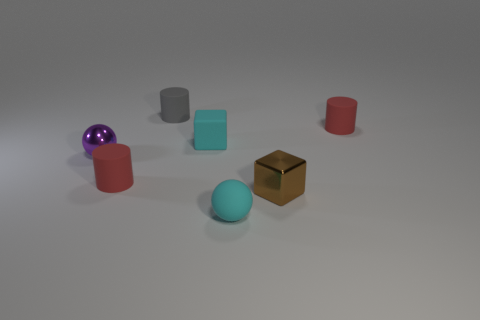Are there any objects in the image that seem out of place? In the context of the image, all objects seem to have been deliberately placed with space around them. Nothing appears to be out of place. They all rest on what looks like a neutral surface which suggests a controlled setup, perhaps for a display or examination of the objects. 